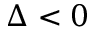<formula> <loc_0><loc_0><loc_500><loc_500>\Delta < 0</formula> 